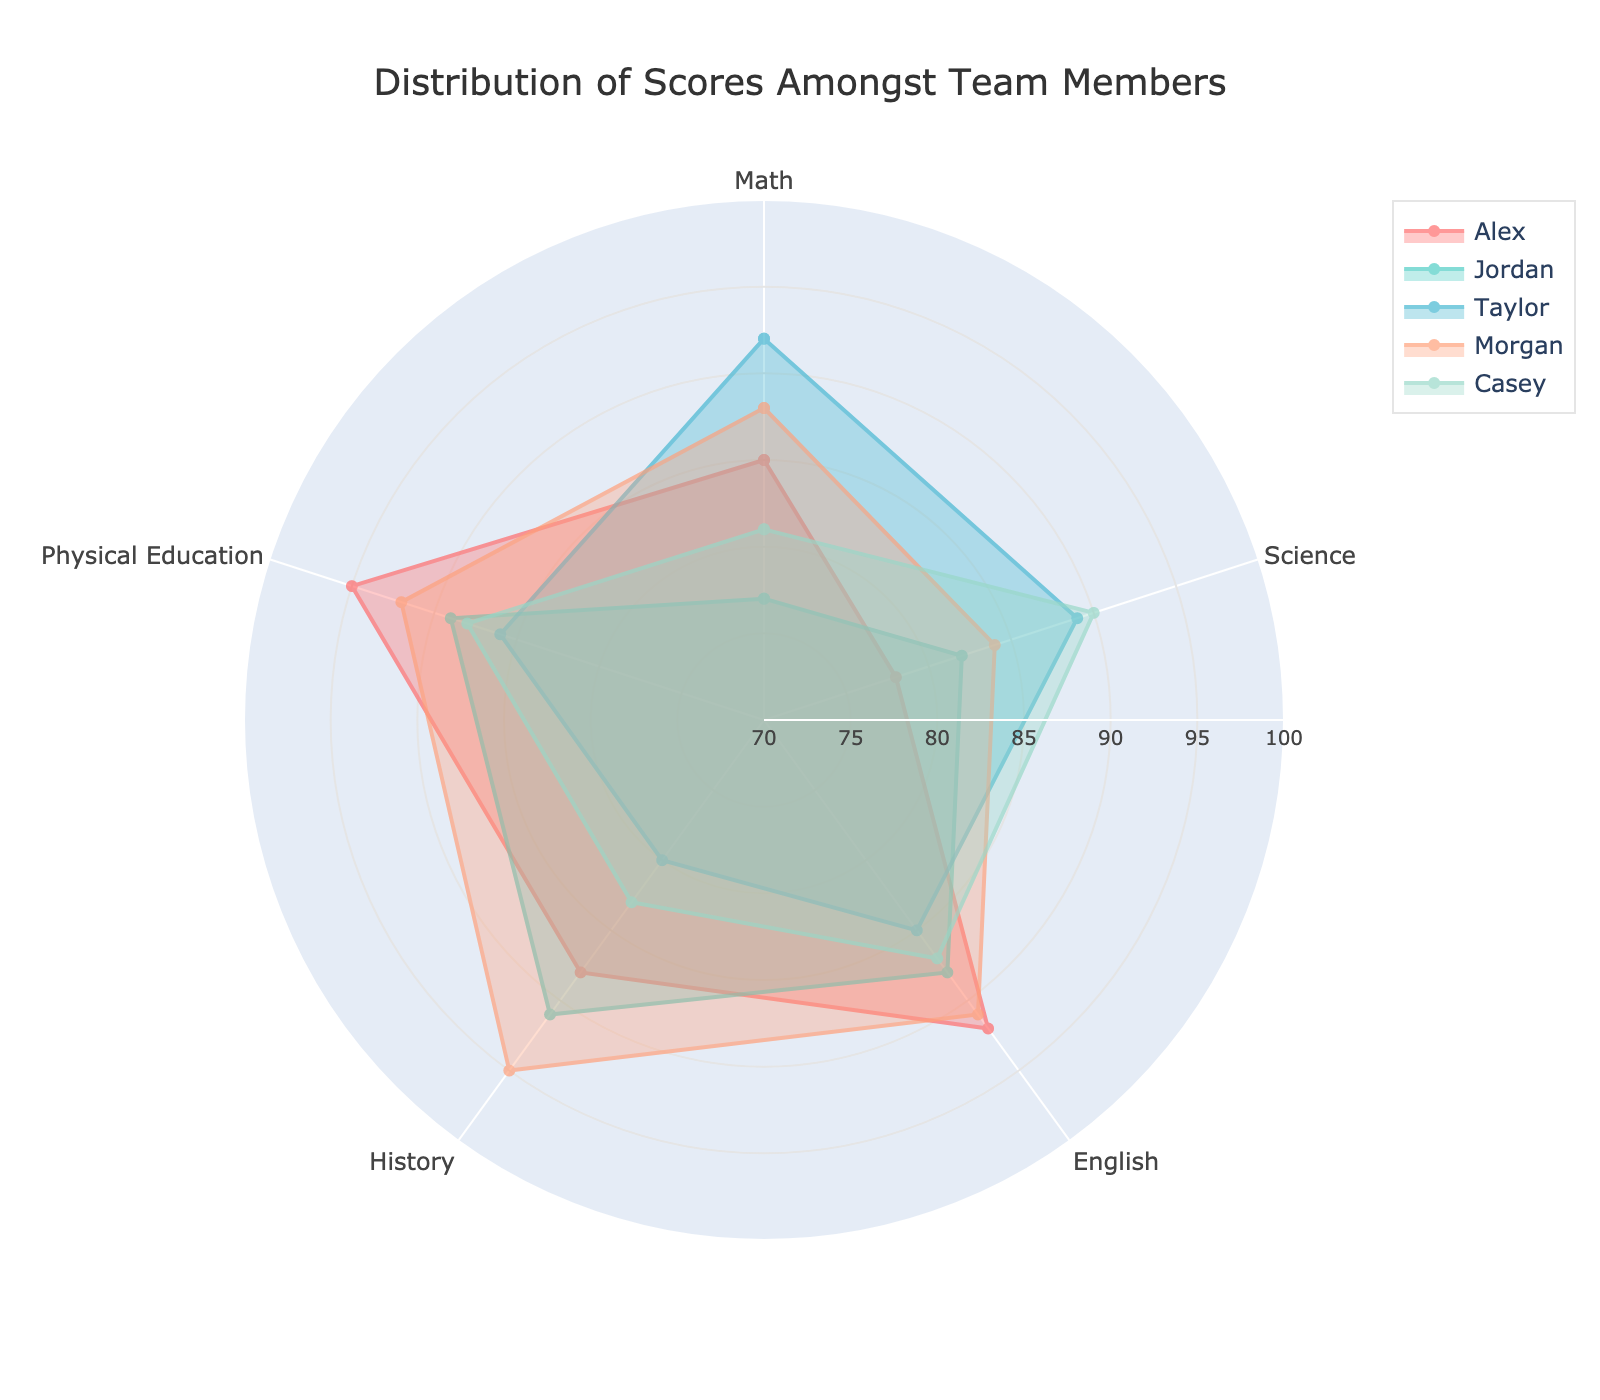What is the title of the polar chart? The title of the polar chart is located at the top and reads as mentioned in the graph's title configuration.
Answer: Distribution of Scores Amongst Team Members How many team members' scores are depicted in the chart? By counting the number of different colored regions or areas within the chart, each representing a distinct team member, we can determine the total number.
Answer: 5 Which subject does Morgan have the highest score in? By examining the scores on the radial axis for each subject, Morgan's highest score is identified in the subject with the highest radial value.
Answer: History What is the overall range of the radial axis? The radial axis range can be seen from the minimum to maximum values provided on the axis in the chart.
Answer: 70 to 100 Whose scores have the greatest variation across the subjects? The greatest variation can be observed by comparing the fluctuations of each team's arc on the polar chart. More significant deviations indicate higher variability. Taylor's scores show notable differences.
Answer: Taylor Which team member has the lowest score in Math and what is the score? By looking at the Math section of the polar chart, the line closest to the center represents the lowest score, and the corresponding radial value denotes the score.
Answer: Jordan, 77 Comparing Alex and Casey, who has a higher score in Physical Education and by how much? Compare the values in the Physical Education section for Alex and Casey. Subtract Casey's score from Alex's score to find the difference.
Answer: Alex by 7 points What is the average score in Science for all team members? Add all the team members' Science scores and divide by the number of team members to calculate the average.
Answer: (78 + 82 + 89 + 84 + 90) / 5 = 84.6 Between Math and English, which subject shows the most consistent scores among all team members? By observing the radial distribution, the subject where the lines are closest to each other across all team members indicates higher consistency.
Answer: Math How many subjects does Taylor have scores above 85? Count the number of subjects where Taylor's score exceeds 85 by looking at the respective radials on the chart.
Answer: 3 